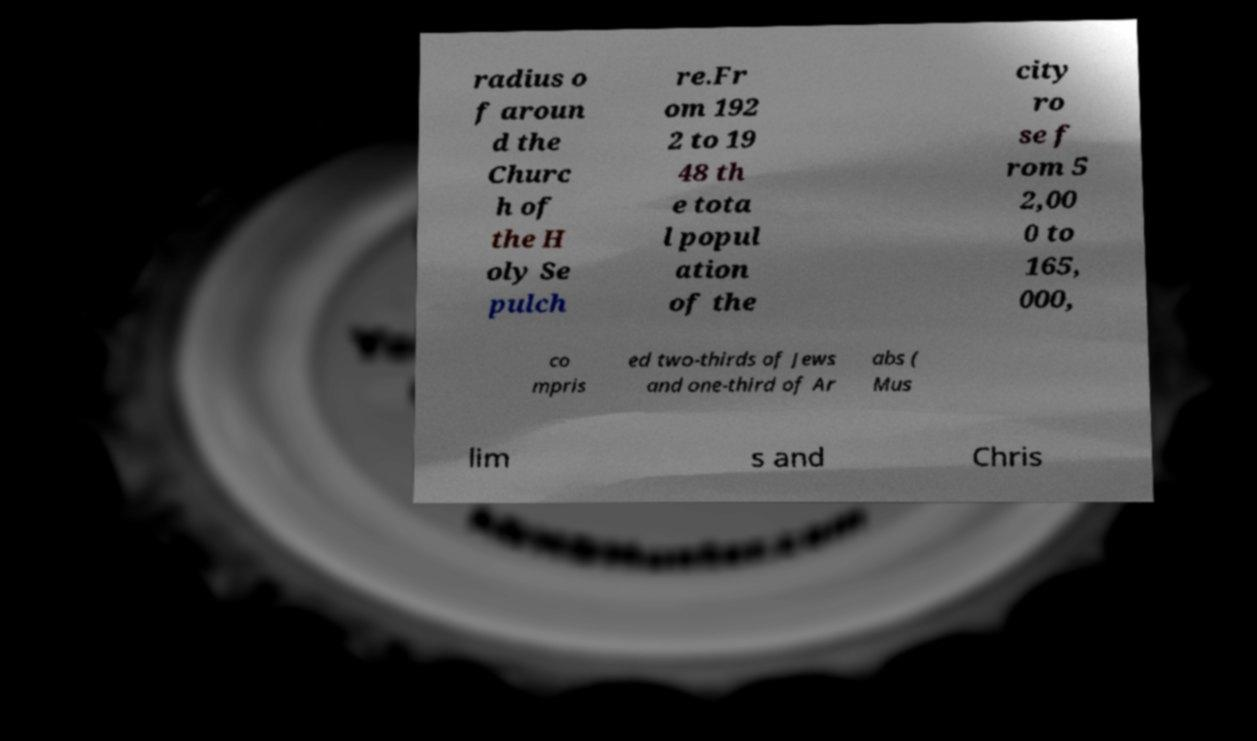Could you extract and type out the text from this image? radius o f aroun d the Churc h of the H oly Se pulch re.Fr om 192 2 to 19 48 th e tota l popul ation of the city ro se f rom 5 2,00 0 to 165, 000, co mpris ed two-thirds of Jews and one-third of Ar abs ( Mus lim s and Chris 